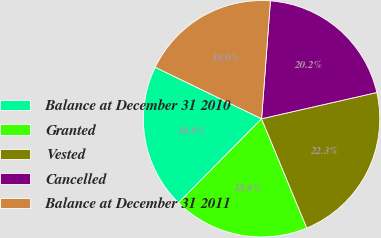Convert chart to OTSL. <chart><loc_0><loc_0><loc_500><loc_500><pie_chart><fcel>Balance at December 31 2010<fcel>Granted<fcel>Vested<fcel>Cancelled<fcel>Balance at December 31 2011<nl><fcel>19.78%<fcel>18.65%<fcel>22.32%<fcel>20.24%<fcel>19.01%<nl></chart> 